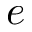<formula> <loc_0><loc_0><loc_500><loc_500>e</formula> 